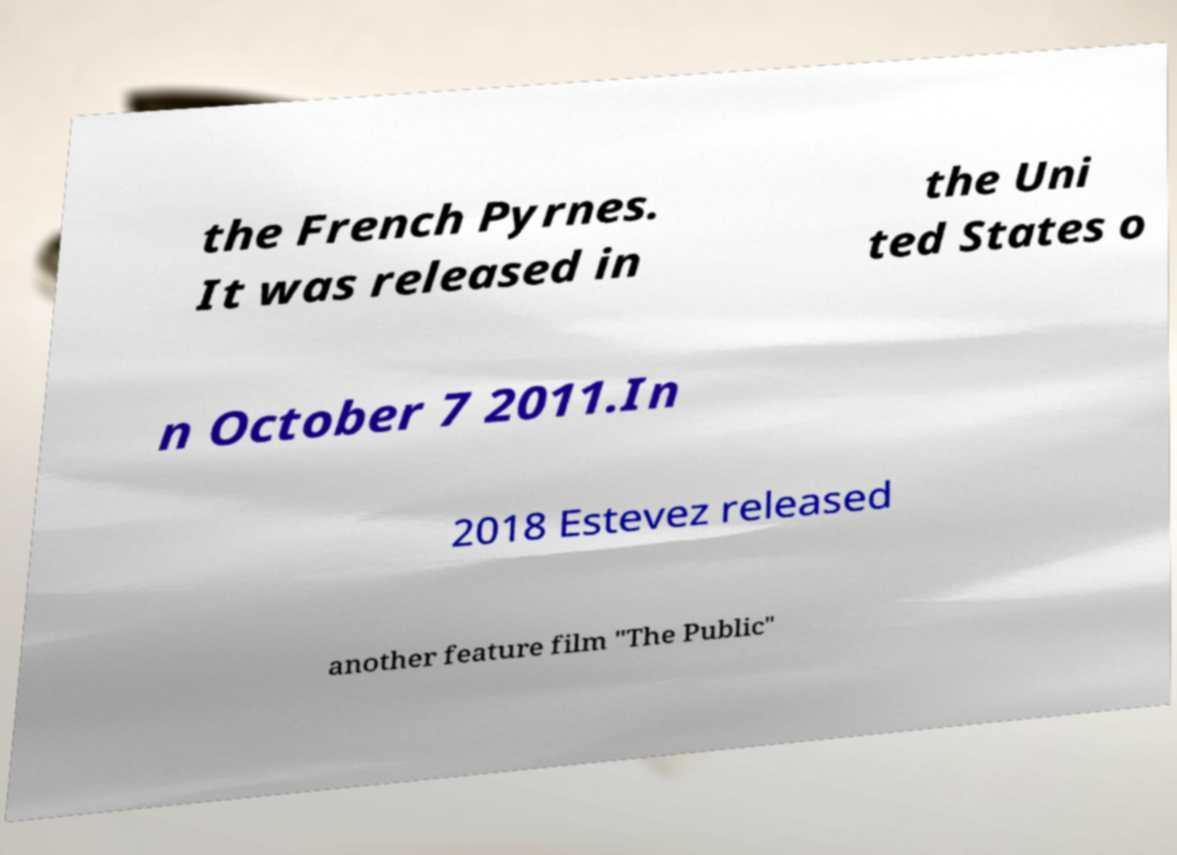Please identify and transcribe the text found in this image. the French Pyrnes. It was released in the Uni ted States o n October 7 2011.In 2018 Estevez released another feature film "The Public" 